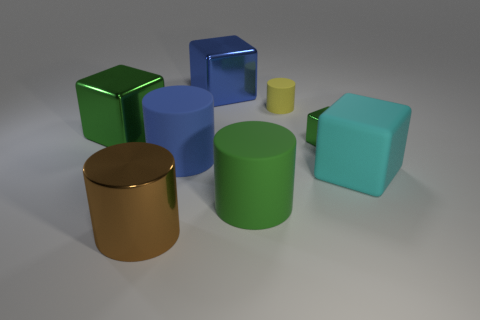Are any large things visible?
Provide a succinct answer. Yes. What is the color of the big metallic thing in front of the large green block?
Your response must be concise. Brown. What is the material of the large block that is the same color as the small shiny thing?
Make the answer very short. Metal. Are there any large blocks behind the cyan matte cube?
Your answer should be compact. Yes. Is the number of yellow objects greater than the number of big yellow cubes?
Your response must be concise. Yes. There is a large metal thing in front of the block that is in front of the metal object that is to the right of the tiny yellow cylinder; what is its color?
Offer a terse response. Brown. What color is the large cylinder that is the same material as the tiny green object?
Your answer should be compact. Brown. What number of objects are either shiny blocks on the left side of the green rubber cylinder or big blocks left of the tiny yellow thing?
Your answer should be very brief. 2. There is a green metallic thing that is to the left of the small rubber cylinder; is it the same size as the yellow object that is on the right side of the blue cylinder?
Ensure brevity in your answer.  No. What is the color of the metallic object that is the same shape as the small rubber thing?
Provide a short and direct response. Brown. 